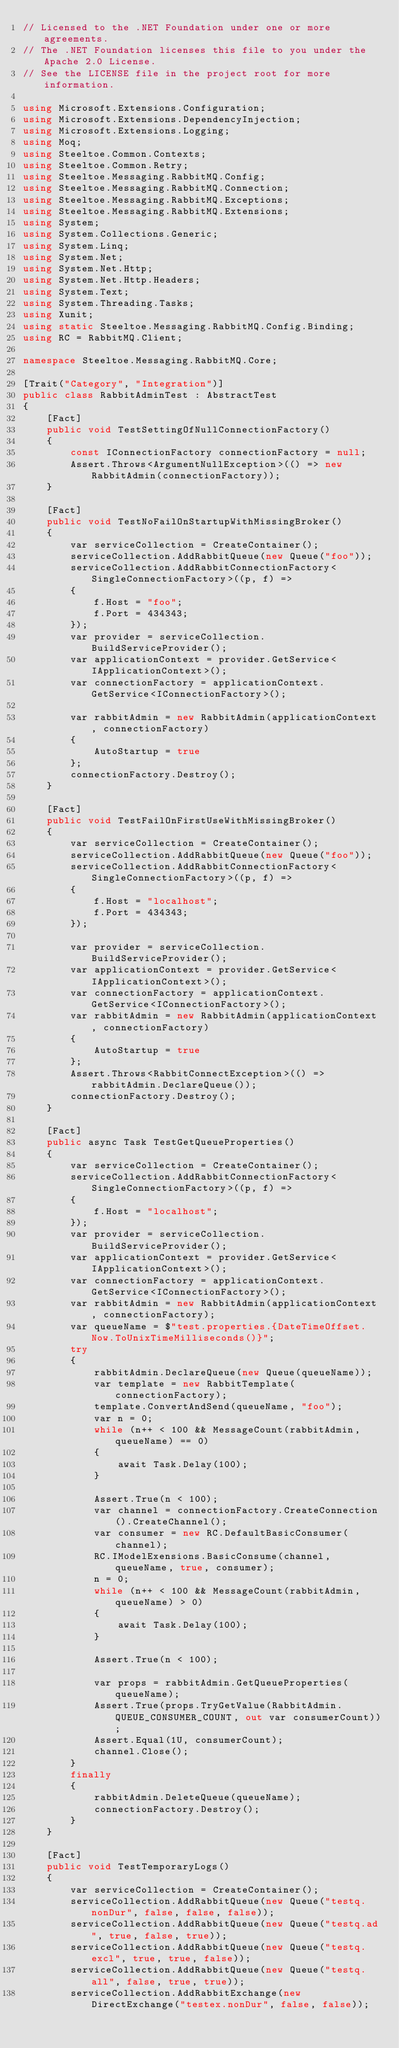Convert code to text. <code><loc_0><loc_0><loc_500><loc_500><_C#_>// Licensed to the .NET Foundation under one or more agreements.
// The .NET Foundation licenses this file to you under the Apache 2.0 License.
// See the LICENSE file in the project root for more information.

using Microsoft.Extensions.Configuration;
using Microsoft.Extensions.DependencyInjection;
using Microsoft.Extensions.Logging;
using Moq;
using Steeltoe.Common.Contexts;
using Steeltoe.Common.Retry;
using Steeltoe.Messaging.RabbitMQ.Config;
using Steeltoe.Messaging.RabbitMQ.Connection;
using Steeltoe.Messaging.RabbitMQ.Exceptions;
using Steeltoe.Messaging.RabbitMQ.Extensions;
using System;
using System.Collections.Generic;
using System.Linq;
using System.Net;
using System.Net.Http;
using System.Net.Http.Headers;
using System.Text;
using System.Threading.Tasks;
using Xunit;
using static Steeltoe.Messaging.RabbitMQ.Config.Binding;
using RC = RabbitMQ.Client;

namespace Steeltoe.Messaging.RabbitMQ.Core;

[Trait("Category", "Integration")]
public class RabbitAdminTest : AbstractTest
{
    [Fact]
    public void TestSettingOfNullConnectionFactory()
    {
        const IConnectionFactory connectionFactory = null;
        Assert.Throws<ArgumentNullException>(() => new RabbitAdmin(connectionFactory));
    }

    [Fact]
    public void TestNoFailOnStartupWithMissingBroker()
    {
        var serviceCollection = CreateContainer();
        serviceCollection.AddRabbitQueue(new Queue("foo"));
        serviceCollection.AddRabbitConnectionFactory<SingleConnectionFactory>((p, f) =>
        {
            f.Host = "foo";
            f.Port = 434343;
        });
        var provider = serviceCollection.BuildServiceProvider();
        var applicationContext = provider.GetService<IApplicationContext>();
        var connectionFactory = applicationContext.GetService<IConnectionFactory>();

        var rabbitAdmin = new RabbitAdmin(applicationContext, connectionFactory)
        {
            AutoStartup = true
        };
        connectionFactory.Destroy();
    }

    [Fact]
    public void TestFailOnFirstUseWithMissingBroker()
    {
        var serviceCollection = CreateContainer();
        serviceCollection.AddRabbitQueue(new Queue("foo"));
        serviceCollection.AddRabbitConnectionFactory<SingleConnectionFactory>((p, f) =>
        {
            f.Host = "localhost";
            f.Port = 434343;
        });

        var provider = serviceCollection.BuildServiceProvider();
        var applicationContext = provider.GetService<IApplicationContext>();
        var connectionFactory = applicationContext.GetService<IConnectionFactory>();
        var rabbitAdmin = new RabbitAdmin(applicationContext, connectionFactory)
        {
            AutoStartup = true
        };
        Assert.Throws<RabbitConnectException>(() => rabbitAdmin.DeclareQueue());
        connectionFactory.Destroy();
    }

    [Fact]
    public async Task TestGetQueueProperties()
    {
        var serviceCollection = CreateContainer();
        serviceCollection.AddRabbitConnectionFactory<SingleConnectionFactory>((p, f) =>
        {
            f.Host = "localhost";
        });
        var provider = serviceCollection.BuildServiceProvider();
        var applicationContext = provider.GetService<IApplicationContext>();
        var connectionFactory = applicationContext.GetService<IConnectionFactory>();
        var rabbitAdmin = new RabbitAdmin(applicationContext, connectionFactory);
        var queueName = $"test.properties.{DateTimeOffset.Now.ToUnixTimeMilliseconds()}";
        try
        {
            rabbitAdmin.DeclareQueue(new Queue(queueName));
            var template = new RabbitTemplate(connectionFactory);
            template.ConvertAndSend(queueName, "foo");
            var n = 0;
            while (n++ < 100 && MessageCount(rabbitAdmin, queueName) == 0)
            {
                await Task.Delay(100);
            }

            Assert.True(n < 100);
            var channel = connectionFactory.CreateConnection().CreateChannel();
            var consumer = new RC.DefaultBasicConsumer(channel);
            RC.IModelExensions.BasicConsume(channel, queueName, true, consumer);
            n = 0;
            while (n++ < 100 && MessageCount(rabbitAdmin, queueName) > 0)
            {
                await Task.Delay(100);
            }

            Assert.True(n < 100);

            var props = rabbitAdmin.GetQueueProperties(queueName);
            Assert.True(props.TryGetValue(RabbitAdmin.QUEUE_CONSUMER_COUNT, out var consumerCount));
            Assert.Equal(1U, consumerCount);
            channel.Close();
        }
        finally
        {
            rabbitAdmin.DeleteQueue(queueName);
            connectionFactory.Destroy();
        }
    }

    [Fact]
    public void TestTemporaryLogs()
    {
        var serviceCollection = CreateContainer();
        serviceCollection.AddRabbitQueue(new Queue("testq.nonDur", false, false, false));
        serviceCollection.AddRabbitQueue(new Queue("testq.ad", true, false, true));
        serviceCollection.AddRabbitQueue(new Queue("testq.excl", true, true, false));
        serviceCollection.AddRabbitQueue(new Queue("testq.all", false, true, true));
        serviceCollection.AddRabbitExchange(new DirectExchange("testex.nonDur", false, false));</code> 